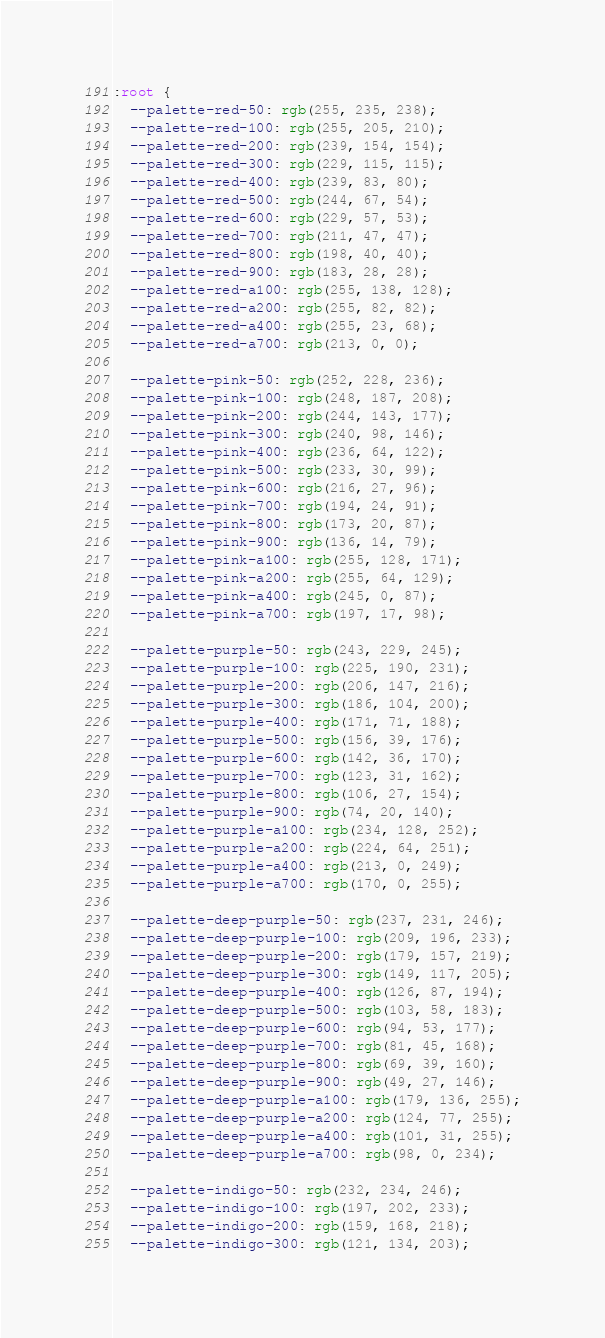<code> <loc_0><loc_0><loc_500><loc_500><_CSS_>:root {
  --palette-red-50: rgb(255, 235, 238);
  --palette-red-100: rgb(255, 205, 210);
  --palette-red-200: rgb(239, 154, 154);
  --palette-red-300: rgb(229, 115, 115);
  --palette-red-400: rgb(239, 83, 80);
  --palette-red-500: rgb(244, 67, 54);
  --palette-red-600: rgb(229, 57, 53);
  --palette-red-700: rgb(211, 47, 47);
  --palette-red-800: rgb(198, 40, 40);
  --palette-red-900: rgb(183, 28, 28);
  --palette-red-a100: rgb(255, 138, 128);
  --palette-red-a200: rgb(255, 82, 82);
  --palette-red-a400: rgb(255, 23, 68);
  --palette-red-a700: rgb(213, 0, 0);

  --palette-pink-50: rgb(252, 228, 236);
  --palette-pink-100: rgb(248, 187, 208);
  --palette-pink-200: rgb(244, 143, 177);
  --palette-pink-300: rgb(240, 98, 146);
  --palette-pink-400: rgb(236, 64, 122);
  --palette-pink-500: rgb(233, 30, 99);
  --palette-pink-600: rgb(216, 27, 96);
  --palette-pink-700: rgb(194, 24, 91);
  --palette-pink-800: rgb(173, 20, 87);
  --palette-pink-900: rgb(136, 14, 79);
  --palette-pink-a100: rgb(255, 128, 171);
  --palette-pink-a200: rgb(255, 64, 129);
  --palette-pink-a400: rgb(245, 0, 87);
  --palette-pink-a700: rgb(197, 17, 98);

  --palette-purple-50: rgb(243, 229, 245);
  --palette-purple-100: rgb(225, 190, 231);
  --palette-purple-200: rgb(206, 147, 216);
  --palette-purple-300: rgb(186, 104, 200);
  --palette-purple-400: rgb(171, 71, 188);
  --palette-purple-500: rgb(156, 39, 176);
  --palette-purple-600: rgb(142, 36, 170);
  --palette-purple-700: rgb(123, 31, 162);
  --palette-purple-800: rgb(106, 27, 154);
  --palette-purple-900: rgb(74, 20, 140);
  --palette-purple-a100: rgb(234, 128, 252);
  --palette-purple-a200: rgb(224, 64, 251);
  --palette-purple-a400: rgb(213, 0, 249);
  --palette-purple-a700: rgb(170, 0, 255);

  --palette-deep-purple-50: rgb(237, 231, 246);
  --palette-deep-purple-100: rgb(209, 196, 233);
  --palette-deep-purple-200: rgb(179, 157, 219);
  --palette-deep-purple-300: rgb(149, 117, 205);
  --palette-deep-purple-400: rgb(126, 87, 194);
  --palette-deep-purple-500: rgb(103, 58, 183);
  --palette-deep-purple-600: rgb(94, 53, 177);
  --palette-deep-purple-700: rgb(81, 45, 168);
  --palette-deep-purple-800: rgb(69, 39, 160);
  --palette-deep-purple-900: rgb(49, 27, 146);
  --palette-deep-purple-a100: rgb(179, 136, 255);
  --palette-deep-purple-a200: rgb(124, 77, 255);
  --palette-deep-purple-a400: rgb(101, 31, 255);
  --palette-deep-purple-a700: rgb(98, 0, 234);

  --palette-indigo-50: rgb(232, 234, 246);
  --palette-indigo-100: rgb(197, 202, 233);
  --palette-indigo-200: rgb(159, 168, 218);
  --palette-indigo-300: rgb(121, 134, 203);</code> 